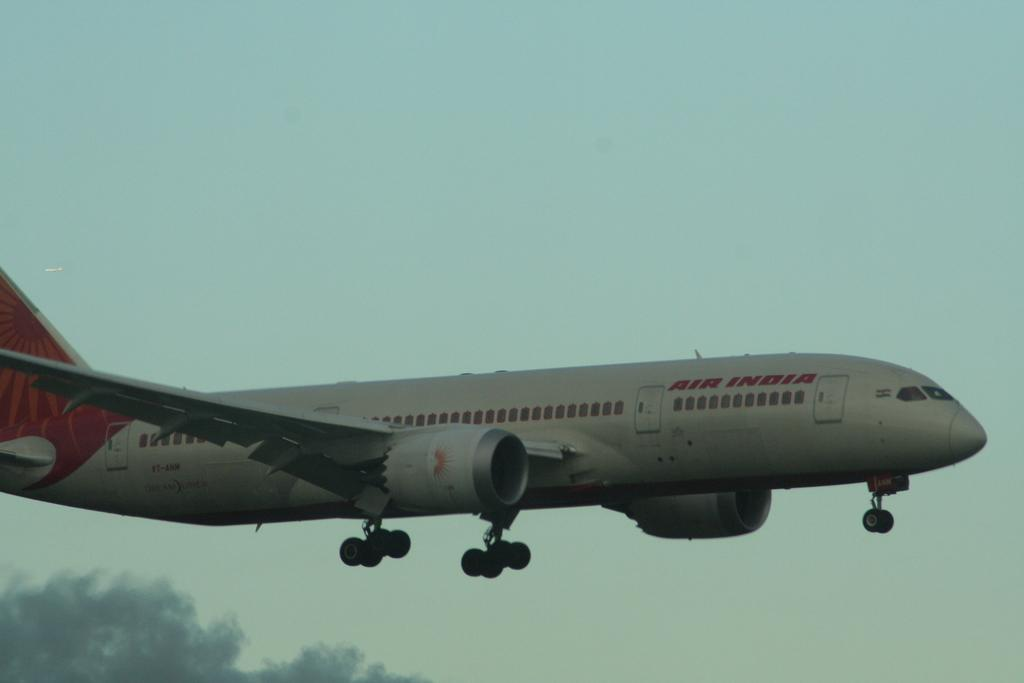What is the main subject in the center of the image? There is an aeroplane in the center of the image. What can be seen at the bottom of the image? There is a tree at the bottom of the image. What is visible in the background of the image? The sky is visible in the background of the image. What type of adjustment is being made to the tree in the image? There is no adjustment being made to the tree in the image; it is simply a tree in its natural state. 